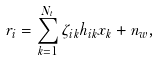<formula> <loc_0><loc_0><loc_500><loc_500>r _ { i } = \sum _ { k = 1 } ^ { N _ { t } } \zeta _ { i k } h _ { i k } x _ { k } + n _ { w } ,</formula> 